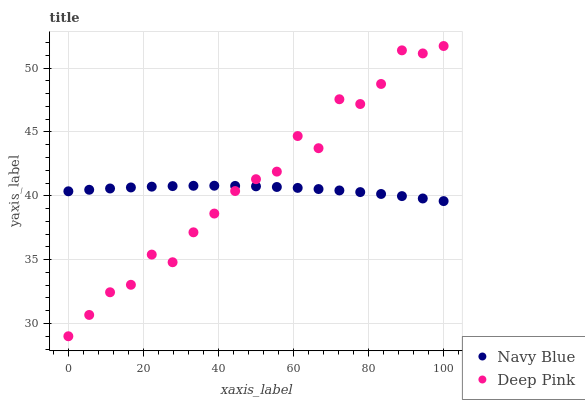Does Navy Blue have the minimum area under the curve?
Answer yes or no. Yes. Does Deep Pink have the maximum area under the curve?
Answer yes or no. Yes. Does Deep Pink have the minimum area under the curve?
Answer yes or no. No. Is Navy Blue the smoothest?
Answer yes or no. Yes. Is Deep Pink the roughest?
Answer yes or no. Yes. Is Deep Pink the smoothest?
Answer yes or no. No. Does Deep Pink have the lowest value?
Answer yes or no. Yes. Does Deep Pink have the highest value?
Answer yes or no. Yes. Does Navy Blue intersect Deep Pink?
Answer yes or no. Yes. Is Navy Blue less than Deep Pink?
Answer yes or no. No. Is Navy Blue greater than Deep Pink?
Answer yes or no. No. 